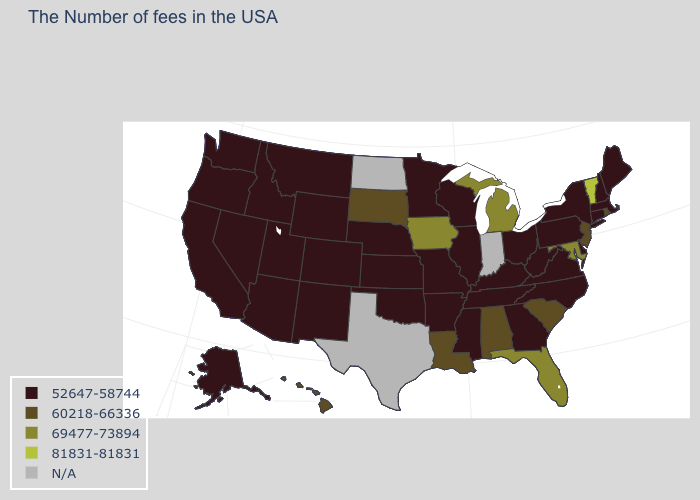What is the value of Ohio?
Concise answer only. 52647-58744. Name the states that have a value in the range 52647-58744?
Give a very brief answer. Maine, Massachusetts, New Hampshire, Connecticut, New York, Delaware, Pennsylvania, Virginia, North Carolina, West Virginia, Ohio, Georgia, Kentucky, Tennessee, Wisconsin, Illinois, Mississippi, Missouri, Arkansas, Minnesota, Kansas, Nebraska, Oklahoma, Wyoming, Colorado, New Mexico, Utah, Montana, Arizona, Idaho, Nevada, California, Washington, Oregon, Alaska. Name the states that have a value in the range 52647-58744?
Give a very brief answer. Maine, Massachusetts, New Hampshire, Connecticut, New York, Delaware, Pennsylvania, Virginia, North Carolina, West Virginia, Ohio, Georgia, Kentucky, Tennessee, Wisconsin, Illinois, Mississippi, Missouri, Arkansas, Minnesota, Kansas, Nebraska, Oklahoma, Wyoming, Colorado, New Mexico, Utah, Montana, Arizona, Idaho, Nevada, California, Washington, Oregon, Alaska. Among the states that border New York , which have the highest value?
Answer briefly. Vermont. What is the value of Connecticut?
Keep it brief. 52647-58744. Which states have the lowest value in the USA?
Keep it brief. Maine, Massachusetts, New Hampshire, Connecticut, New York, Delaware, Pennsylvania, Virginia, North Carolina, West Virginia, Ohio, Georgia, Kentucky, Tennessee, Wisconsin, Illinois, Mississippi, Missouri, Arkansas, Minnesota, Kansas, Nebraska, Oklahoma, Wyoming, Colorado, New Mexico, Utah, Montana, Arizona, Idaho, Nevada, California, Washington, Oregon, Alaska. Does the first symbol in the legend represent the smallest category?
Give a very brief answer. Yes. Name the states that have a value in the range N/A?
Keep it brief. Indiana, Texas, North Dakota. Does Colorado have the highest value in the USA?
Keep it brief. No. Does the map have missing data?
Short answer required. Yes. Which states have the highest value in the USA?
Keep it brief. Vermont. Name the states that have a value in the range 69477-73894?
Give a very brief answer. Maryland, Florida, Michigan, Iowa. 